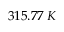Convert formula to latex. <formula><loc_0><loc_0><loc_500><loc_500>3 1 5 . 7 7 \, K</formula> 